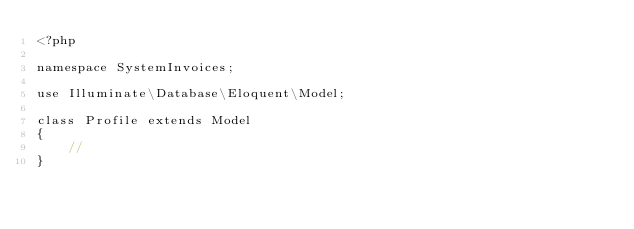Convert code to text. <code><loc_0><loc_0><loc_500><loc_500><_PHP_><?php

namespace SystemInvoices;

use Illuminate\Database\Eloquent\Model;

class Profile extends Model
{
    //
}
</code> 